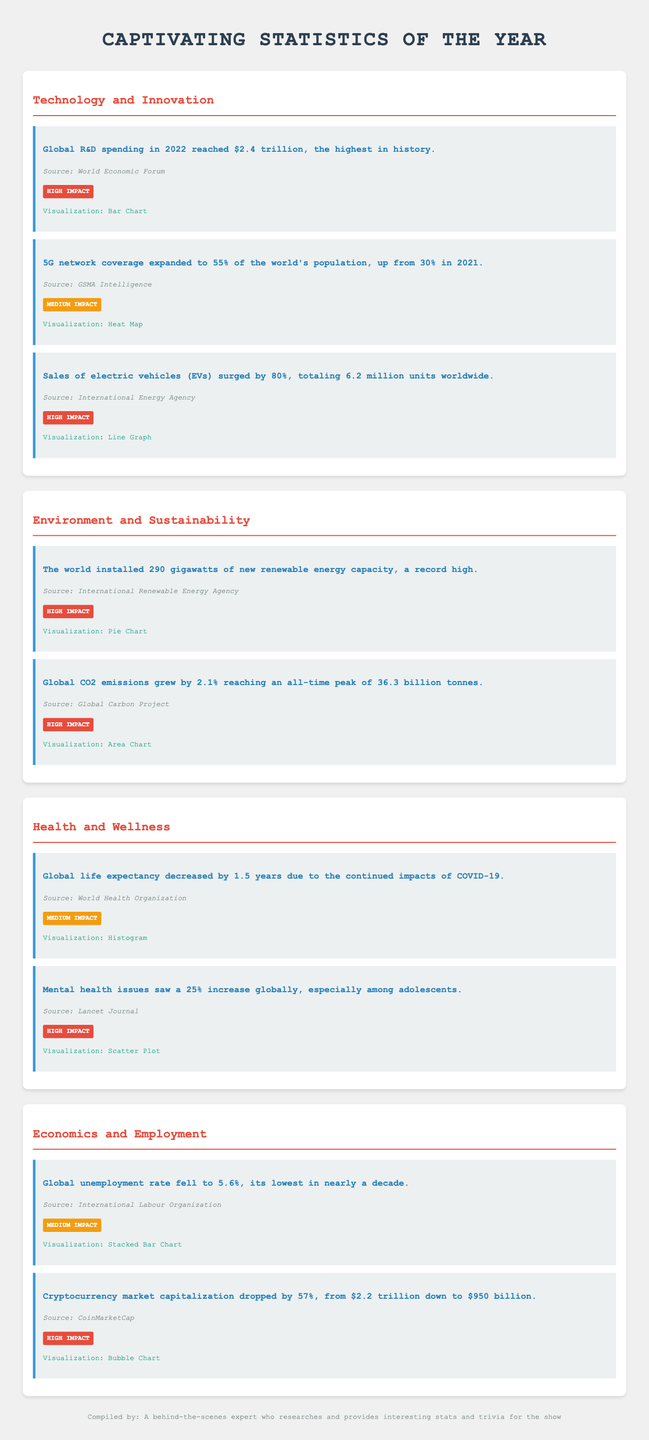What was the global R&D spending in 2022? The document states that global R&D spending in 2022 reached $2.4 trillion, which is the highest in history.
Answer: $2.4 trillion What proportion of the world's population had 5G network coverage in 2022? The document indicates that 5G network coverage expanded to 55% of the world's population in 2022.
Answer: 55% How much did electric vehicle sales increase in 2022? The sales of electric vehicles surged by 80% in 2022.
Answer: 80% What was the record high for new renewable energy capacity installed? The document notes that the world installed 290 gigawatts of new renewable energy capacity, a record high.
Answer: 290 gigawatts By how much did global CO2 emissions grow in 2022? The document mentions that global CO2 emissions grew by 2.1% reaching an all-time peak of 36.3 billion tonnes.
Answer: 2.1% What was the change in global life expectancy due to COVID-19? It states that global life expectancy decreased by 1.5 years due to the continued impacts of COVID-19.
Answer: 1.5 years What was the global unemployment rate in 2022? The document reports that the global unemployment rate fell to 5.6%, its lowest in nearly a decade.
Answer: 5.6% What was the cryptocurrency market capitalization in 2022? The document indicates that the cryptocurrency market capitalization dropped to $950 billion.
Answer: $950 billion What is the primary focus of the statistics presented in the document? The statistics presented focus on various areas such as technology, environment, health, and economics.
Answer: Technology and Innovation, Environment and Sustainability, Health and Wellness, Economics and Employment 